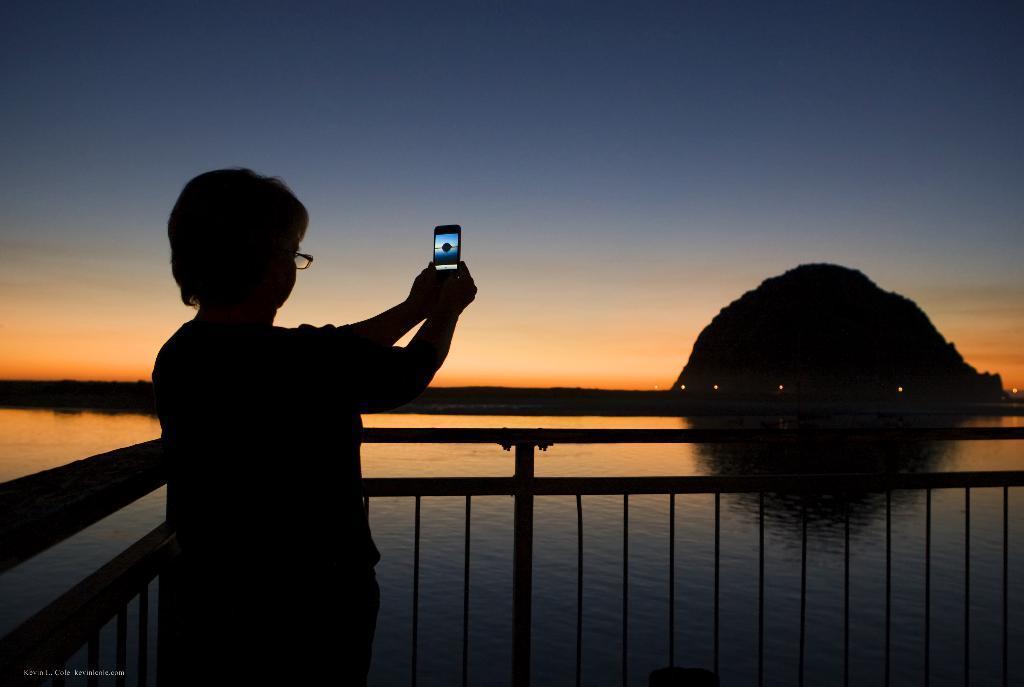In one or two sentences, can you explain what this image depicts? On the left side of the image there is a person. On the right side of the image there is a hill. In the center there is a fencing. In the background there is a sky and water. 